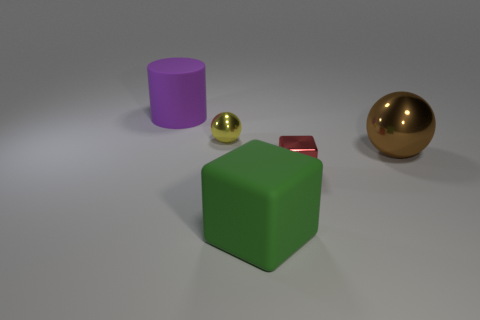There is a large matte thing behind the big brown metallic thing; are there any metal spheres in front of it? It's not entirely clear what is referred to as the 'big brown metallic thing' in the image; however, interpreting the large gold-colored sphere as the object in question, I can confirm that there are indeed two spheres present in the image. One sphere is gold and metallic, substantial in size and lustrous, and the other is smaller with a metallic sheen, suggesting it could be made of metal as well. 